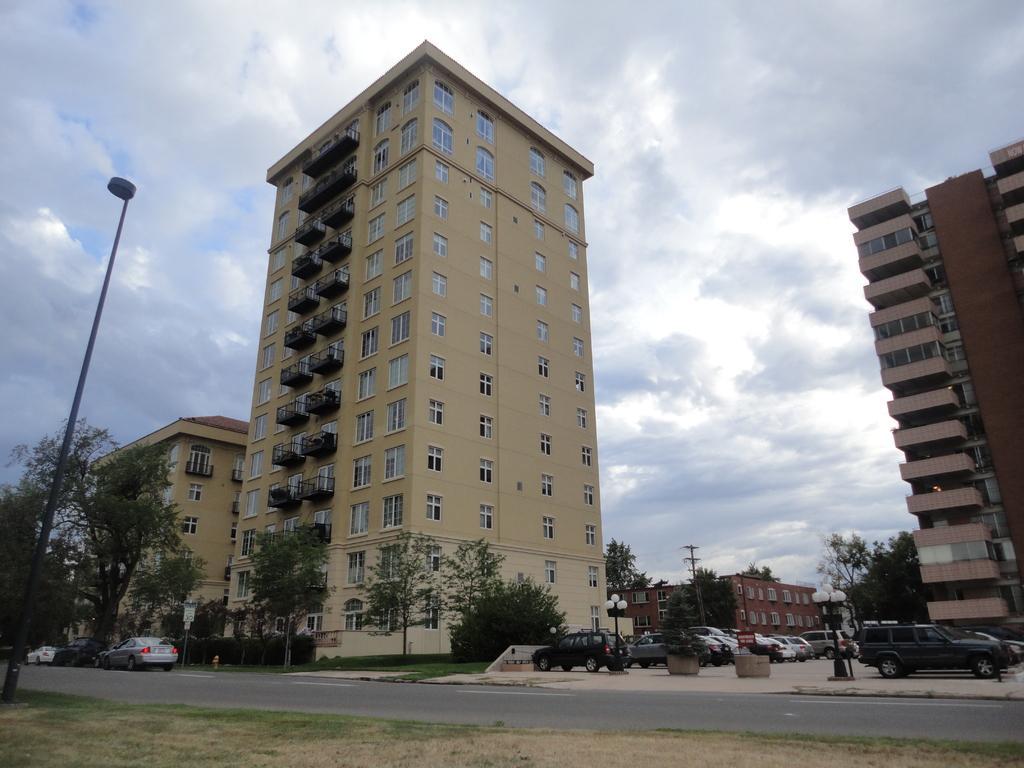Can you describe this image briefly? In this picture there is a building in the center with windows and hand-grills. It is in light yellow in color. Before it there is a road. Beside it there are vehicles parked on the footpath. Towards the right, there is another building. Towards the left, there is a building, tree and a pole. In the background there are buildings trees and a sky. 